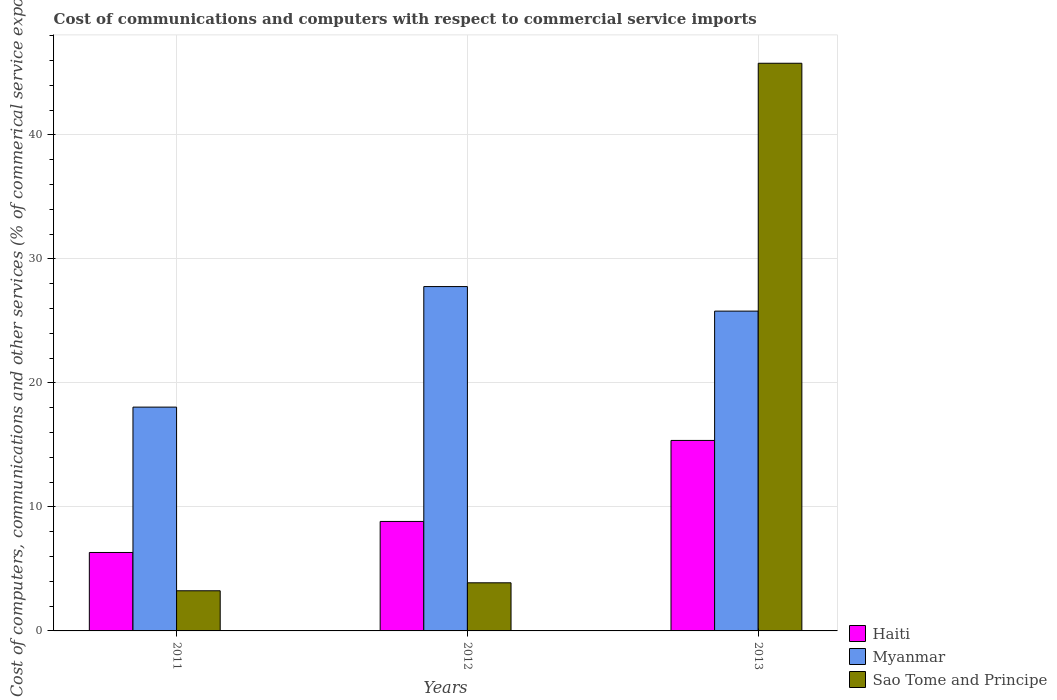Are the number of bars on each tick of the X-axis equal?
Offer a terse response. Yes. How many bars are there on the 1st tick from the left?
Offer a very short reply. 3. How many bars are there on the 2nd tick from the right?
Offer a terse response. 3. In how many cases, is the number of bars for a given year not equal to the number of legend labels?
Provide a short and direct response. 0. What is the cost of communications and computers in Sao Tome and Principe in 2013?
Offer a terse response. 45.78. Across all years, what is the maximum cost of communications and computers in Myanmar?
Provide a succinct answer. 27.77. Across all years, what is the minimum cost of communications and computers in Sao Tome and Principe?
Keep it short and to the point. 3.24. In which year was the cost of communications and computers in Myanmar maximum?
Your response must be concise. 2012. In which year was the cost of communications and computers in Myanmar minimum?
Provide a succinct answer. 2011. What is the total cost of communications and computers in Myanmar in the graph?
Offer a terse response. 71.61. What is the difference between the cost of communications and computers in Haiti in 2012 and that in 2013?
Give a very brief answer. -6.53. What is the difference between the cost of communications and computers in Haiti in 2012 and the cost of communications and computers in Myanmar in 2013?
Your response must be concise. -16.96. What is the average cost of communications and computers in Myanmar per year?
Your answer should be very brief. 23.87. In the year 2012, what is the difference between the cost of communications and computers in Myanmar and cost of communications and computers in Haiti?
Offer a very short reply. 18.94. What is the ratio of the cost of communications and computers in Sao Tome and Principe in 2011 to that in 2013?
Your answer should be very brief. 0.07. Is the cost of communications and computers in Sao Tome and Principe in 2012 less than that in 2013?
Offer a very short reply. Yes. Is the difference between the cost of communications and computers in Myanmar in 2012 and 2013 greater than the difference between the cost of communications and computers in Haiti in 2012 and 2013?
Provide a succinct answer. Yes. What is the difference between the highest and the second highest cost of communications and computers in Sao Tome and Principe?
Your answer should be compact. 41.9. What is the difference between the highest and the lowest cost of communications and computers in Myanmar?
Your answer should be compact. 9.72. What does the 1st bar from the left in 2013 represents?
Give a very brief answer. Haiti. What does the 3rd bar from the right in 2012 represents?
Your answer should be compact. Haiti. How many bars are there?
Your answer should be very brief. 9. Are all the bars in the graph horizontal?
Offer a very short reply. No. How many years are there in the graph?
Make the answer very short. 3. Are the values on the major ticks of Y-axis written in scientific E-notation?
Provide a succinct answer. No. Where does the legend appear in the graph?
Your answer should be compact. Bottom right. How many legend labels are there?
Offer a terse response. 3. How are the legend labels stacked?
Keep it short and to the point. Vertical. What is the title of the graph?
Keep it short and to the point. Cost of communications and computers with respect to commercial service imports. Does "Belarus" appear as one of the legend labels in the graph?
Provide a short and direct response. No. What is the label or title of the Y-axis?
Make the answer very short. Cost of computers, communications and other services (% of commerical service exports). What is the Cost of computers, communications and other services (% of commerical service exports) of Haiti in 2011?
Keep it short and to the point. 6.33. What is the Cost of computers, communications and other services (% of commerical service exports) of Myanmar in 2011?
Offer a terse response. 18.05. What is the Cost of computers, communications and other services (% of commerical service exports) of Sao Tome and Principe in 2011?
Your response must be concise. 3.24. What is the Cost of computers, communications and other services (% of commerical service exports) in Haiti in 2012?
Your answer should be compact. 8.83. What is the Cost of computers, communications and other services (% of commerical service exports) of Myanmar in 2012?
Your response must be concise. 27.77. What is the Cost of computers, communications and other services (% of commerical service exports) in Sao Tome and Principe in 2012?
Provide a succinct answer. 3.88. What is the Cost of computers, communications and other services (% of commerical service exports) in Haiti in 2013?
Offer a very short reply. 15.36. What is the Cost of computers, communications and other services (% of commerical service exports) of Myanmar in 2013?
Your answer should be very brief. 25.79. What is the Cost of computers, communications and other services (% of commerical service exports) of Sao Tome and Principe in 2013?
Ensure brevity in your answer.  45.78. Across all years, what is the maximum Cost of computers, communications and other services (% of commerical service exports) in Haiti?
Ensure brevity in your answer.  15.36. Across all years, what is the maximum Cost of computers, communications and other services (% of commerical service exports) of Myanmar?
Ensure brevity in your answer.  27.77. Across all years, what is the maximum Cost of computers, communications and other services (% of commerical service exports) in Sao Tome and Principe?
Offer a very short reply. 45.78. Across all years, what is the minimum Cost of computers, communications and other services (% of commerical service exports) of Haiti?
Make the answer very short. 6.33. Across all years, what is the minimum Cost of computers, communications and other services (% of commerical service exports) in Myanmar?
Make the answer very short. 18.05. Across all years, what is the minimum Cost of computers, communications and other services (% of commerical service exports) in Sao Tome and Principe?
Give a very brief answer. 3.24. What is the total Cost of computers, communications and other services (% of commerical service exports) of Haiti in the graph?
Offer a very short reply. 30.52. What is the total Cost of computers, communications and other services (% of commerical service exports) of Myanmar in the graph?
Provide a succinct answer. 71.61. What is the total Cost of computers, communications and other services (% of commerical service exports) in Sao Tome and Principe in the graph?
Provide a short and direct response. 52.9. What is the difference between the Cost of computers, communications and other services (% of commerical service exports) of Haiti in 2011 and that in 2012?
Your answer should be compact. -2.5. What is the difference between the Cost of computers, communications and other services (% of commerical service exports) of Myanmar in 2011 and that in 2012?
Give a very brief answer. -9.72. What is the difference between the Cost of computers, communications and other services (% of commerical service exports) in Sao Tome and Principe in 2011 and that in 2012?
Offer a very short reply. -0.64. What is the difference between the Cost of computers, communications and other services (% of commerical service exports) in Haiti in 2011 and that in 2013?
Make the answer very short. -9.04. What is the difference between the Cost of computers, communications and other services (% of commerical service exports) in Myanmar in 2011 and that in 2013?
Give a very brief answer. -7.74. What is the difference between the Cost of computers, communications and other services (% of commerical service exports) of Sao Tome and Principe in 2011 and that in 2013?
Offer a terse response. -42.54. What is the difference between the Cost of computers, communications and other services (% of commerical service exports) of Haiti in 2012 and that in 2013?
Ensure brevity in your answer.  -6.53. What is the difference between the Cost of computers, communications and other services (% of commerical service exports) in Myanmar in 2012 and that in 2013?
Make the answer very short. 1.98. What is the difference between the Cost of computers, communications and other services (% of commerical service exports) in Sao Tome and Principe in 2012 and that in 2013?
Provide a short and direct response. -41.9. What is the difference between the Cost of computers, communications and other services (% of commerical service exports) in Haiti in 2011 and the Cost of computers, communications and other services (% of commerical service exports) in Myanmar in 2012?
Provide a succinct answer. -21.44. What is the difference between the Cost of computers, communications and other services (% of commerical service exports) of Haiti in 2011 and the Cost of computers, communications and other services (% of commerical service exports) of Sao Tome and Principe in 2012?
Your answer should be very brief. 2.45. What is the difference between the Cost of computers, communications and other services (% of commerical service exports) in Myanmar in 2011 and the Cost of computers, communications and other services (% of commerical service exports) in Sao Tome and Principe in 2012?
Your answer should be compact. 14.17. What is the difference between the Cost of computers, communications and other services (% of commerical service exports) of Haiti in 2011 and the Cost of computers, communications and other services (% of commerical service exports) of Myanmar in 2013?
Keep it short and to the point. -19.46. What is the difference between the Cost of computers, communications and other services (% of commerical service exports) of Haiti in 2011 and the Cost of computers, communications and other services (% of commerical service exports) of Sao Tome and Principe in 2013?
Your response must be concise. -39.45. What is the difference between the Cost of computers, communications and other services (% of commerical service exports) in Myanmar in 2011 and the Cost of computers, communications and other services (% of commerical service exports) in Sao Tome and Principe in 2013?
Offer a terse response. -27.73. What is the difference between the Cost of computers, communications and other services (% of commerical service exports) in Haiti in 2012 and the Cost of computers, communications and other services (% of commerical service exports) in Myanmar in 2013?
Your answer should be very brief. -16.96. What is the difference between the Cost of computers, communications and other services (% of commerical service exports) in Haiti in 2012 and the Cost of computers, communications and other services (% of commerical service exports) in Sao Tome and Principe in 2013?
Make the answer very short. -36.95. What is the difference between the Cost of computers, communications and other services (% of commerical service exports) of Myanmar in 2012 and the Cost of computers, communications and other services (% of commerical service exports) of Sao Tome and Principe in 2013?
Give a very brief answer. -18.01. What is the average Cost of computers, communications and other services (% of commerical service exports) of Haiti per year?
Provide a succinct answer. 10.17. What is the average Cost of computers, communications and other services (% of commerical service exports) of Myanmar per year?
Provide a succinct answer. 23.87. What is the average Cost of computers, communications and other services (% of commerical service exports) in Sao Tome and Principe per year?
Offer a very short reply. 17.63. In the year 2011, what is the difference between the Cost of computers, communications and other services (% of commerical service exports) of Haiti and Cost of computers, communications and other services (% of commerical service exports) of Myanmar?
Give a very brief answer. -11.72. In the year 2011, what is the difference between the Cost of computers, communications and other services (% of commerical service exports) of Haiti and Cost of computers, communications and other services (% of commerical service exports) of Sao Tome and Principe?
Your answer should be compact. 3.09. In the year 2011, what is the difference between the Cost of computers, communications and other services (% of commerical service exports) in Myanmar and Cost of computers, communications and other services (% of commerical service exports) in Sao Tome and Principe?
Your response must be concise. 14.81. In the year 2012, what is the difference between the Cost of computers, communications and other services (% of commerical service exports) in Haiti and Cost of computers, communications and other services (% of commerical service exports) in Myanmar?
Provide a short and direct response. -18.94. In the year 2012, what is the difference between the Cost of computers, communications and other services (% of commerical service exports) of Haiti and Cost of computers, communications and other services (% of commerical service exports) of Sao Tome and Principe?
Offer a very short reply. 4.95. In the year 2012, what is the difference between the Cost of computers, communications and other services (% of commerical service exports) in Myanmar and Cost of computers, communications and other services (% of commerical service exports) in Sao Tome and Principe?
Make the answer very short. 23.89. In the year 2013, what is the difference between the Cost of computers, communications and other services (% of commerical service exports) of Haiti and Cost of computers, communications and other services (% of commerical service exports) of Myanmar?
Offer a terse response. -10.43. In the year 2013, what is the difference between the Cost of computers, communications and other services (% of commerical service exports) in Haiti and Cost of computers, communications and other services (% of commerical service exports) in Sao Tome and Principe?
Keep it short and to the point. -30.42. In the year 2013, what is the difference between the Cost of computers, communications and other services (% of commerical service exports) in Myanmar and Cost of computers, communications and other services (% of commerical service exports) in Sao Tome and Principe?
Provide a short and direct response. -19.99. What is the ratio of the Cost of computers, communications and other services (% of commerical service exports) in Haiti in 2011 to that in 2012?
Your answer should be compact. 0.72. What is the ratio of the Cost of computers, communications and other services (% of commerical service exports) of Myanmar in 2011 to that in 2012?
Offer a very short reply. 0.65. What is the ratio of the Cost of computers, communications and other services (% of commerical service exports) of Sao Tome and Principe in 2011 to that in 2012?
Offer a very short reply. 0.83. What is the ratio of the Cost of computers, communications and other services (% of commerical service exports) in Haiti in 2011 to that in 2013?
Make the answer very short. 0.41. What is the ratio of the Cost of computers, communications and other services (% of commerical service exports) of Myanmar in 2011 to that in 2013?
Offer a terse response. 0.7. What is the ratio of the Cost of computers, communications and other services (% of commerical service exports) in Sao Tome and Principe in 2011 to that in 2013?
Give a very brief answer. 0.07. What is the ratio of the Cost of computers, communications and other services (% of commerical service exports) in Haiti in 2012 to that in 2013?
Keep it short and to the point. 0.57. What is the ratio of the Cost of computers, communications and other services (% of commerical service exports) of Myanmar in 2012 to that in 2013?
Give a very brief answer. 1.08. What is the ratio of the Cost of computers, communications and other services (% of commerical service exports) of Sao Tome and Principe in 2012 to that in 2013?
Make the answer very short. 0.08. What is the difference between the highest and the second highest Cost of computers, communications and other services (% of commerical service exports) of Haiti?
Your response must be concise. 6.53. What is the difference between the highest and the second highest Cost of computers, communications and other services (% of commerical service exports) in Myanmar?
Offer a very short reply. 1.98. What is the difference between the highest and the second highest Cost of computers, communications and other services (% of commerical service exports) of Sao Tome and Principe?
Provide a succinct answer. 41.9. What is the difference between the highest and the lowest Cost of computers, communications and other services (% of commerical service exports) of Haiti?
Keep it short and to the point. 9.04. What is the difference between the highest and the lowest Cost of computers, communications and other services (% of commerical service exports) of Myanmar?
Make the answer very short. 9.72. What is the difference between the highest and the lowest Cost of computers, communications and other services (% of commerical service exports) of Sao Tome and Principe?
Keep it short and to the point. 42.54. 